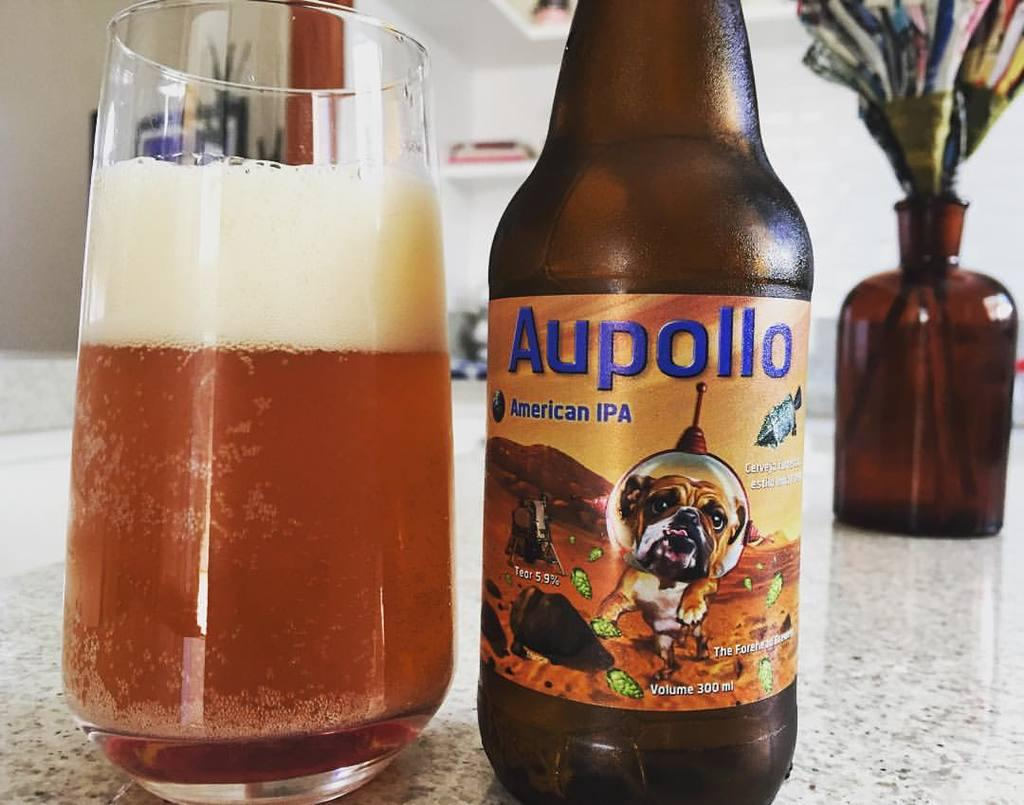<image>
Summarize the visual content of the image. Half full glass sits on a counter next to a bottle of Aupollo. 